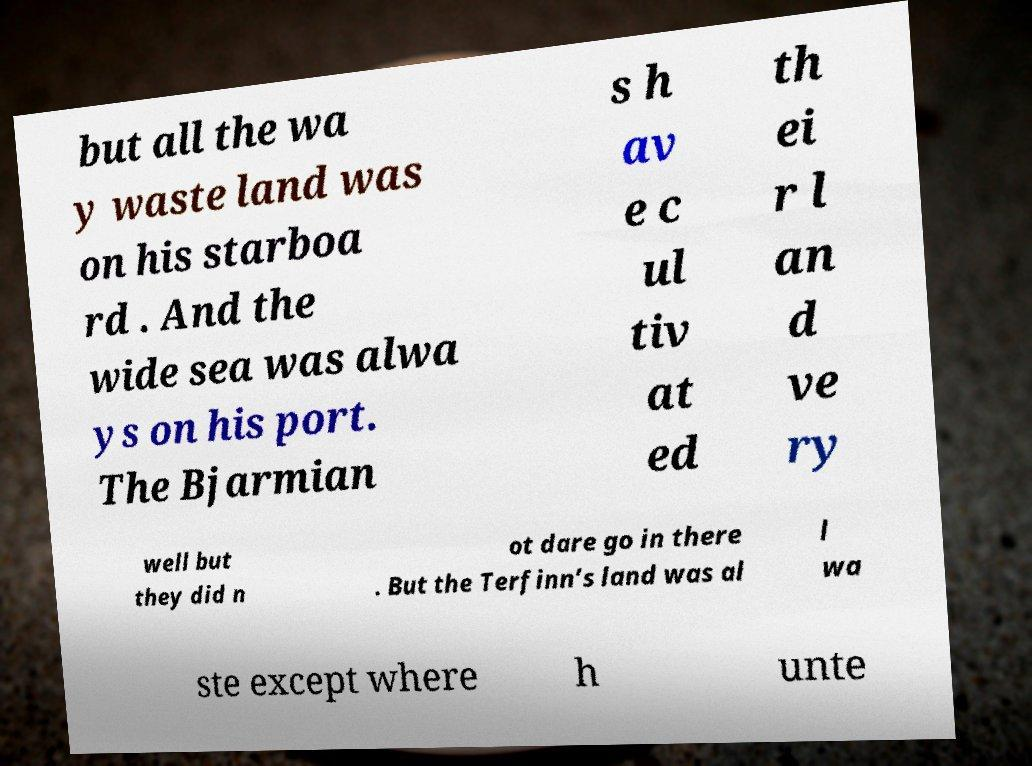I need the written content from this picture converted into text. Can you do that? but all the wa y waste land was on his starboa rd . And the wide sea was alwa ys on his port. The Bjarmian s h av e c ul tiv at ed th ei r l an d ve ry well but they did n ot dare go in there . But the Terfinn’s land was al l wa ste except where h unte 